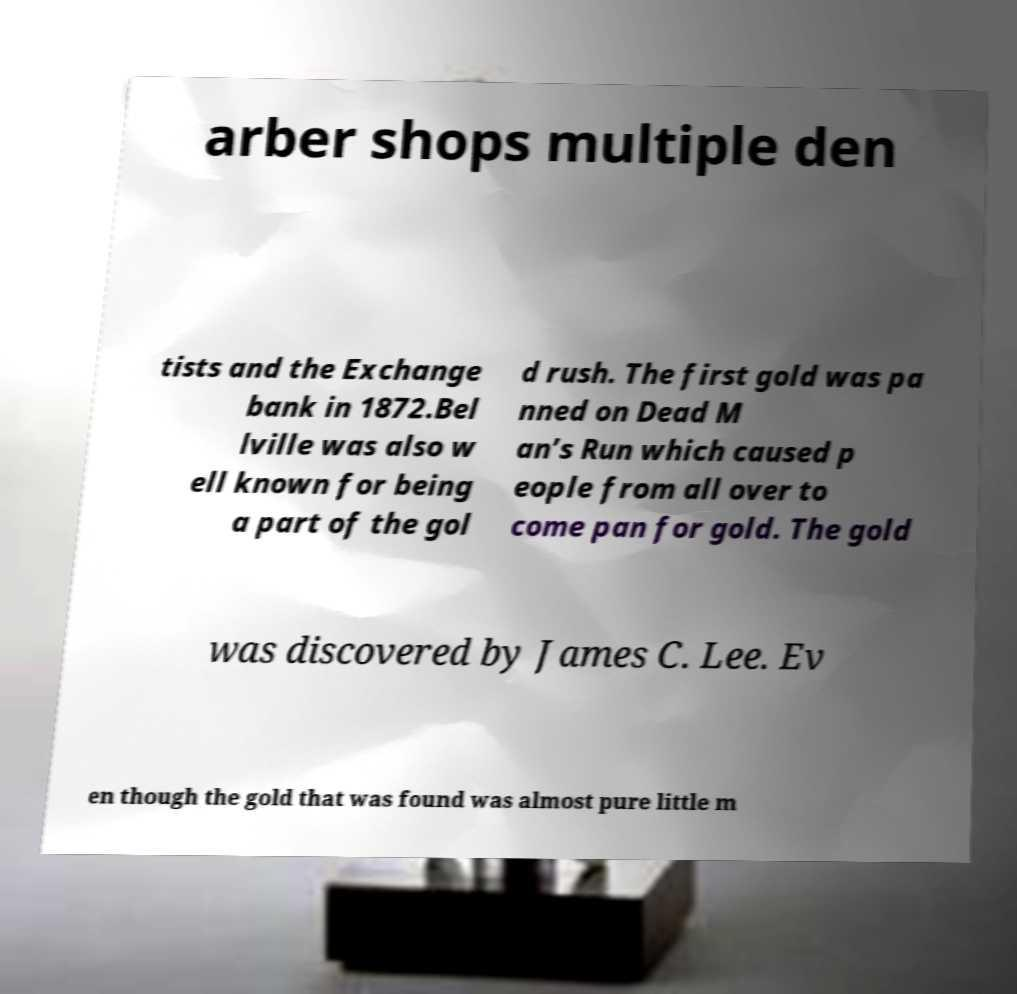Could you extract and type out the text from this image? arber shops multiple den tists and the Exchange bank in 1872.Bel lville was also w ell known for being a part of the gol d rush. The first gold was pa nned on Dead M an’s Run which caused p eople from all over to come pan for gold. The gold was discovered by James C. Lee. Ev en though the gold that was found was almost pure little m 